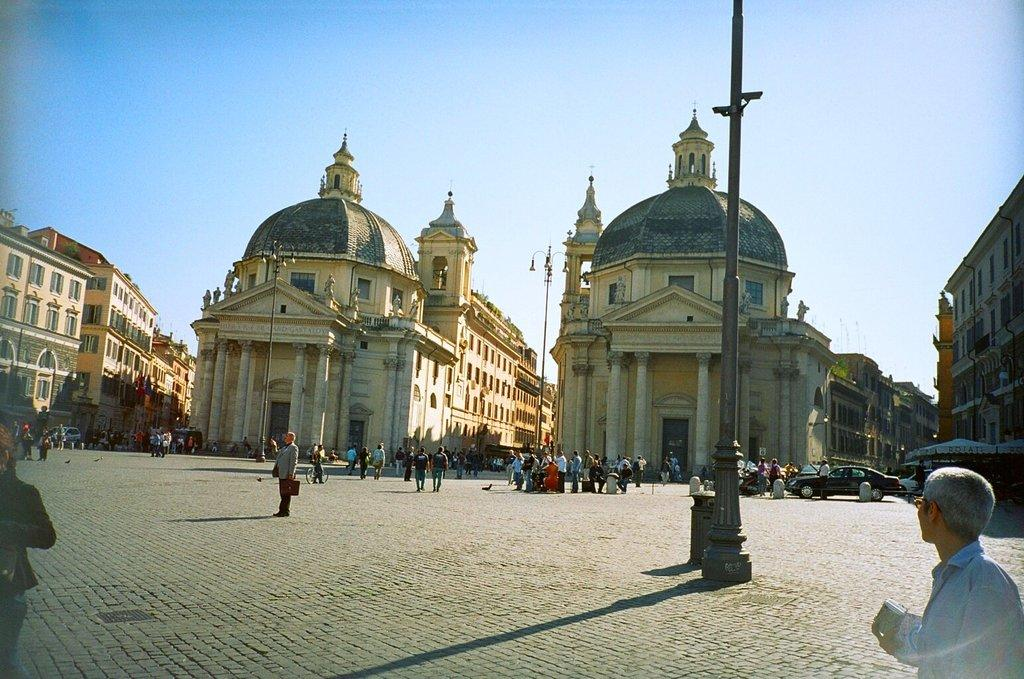What type of structures are present in the image? There are buildings in the image. What else can be seen in the image besides the buildings? There are people standing in the image. What other objects are visible in the image? There are vehicles in the image. Where is the place where the ducks are swimming in the image? There are no ducks present in the image. What type of flesh can be seen in the image? There is no flesh visible in the image. 